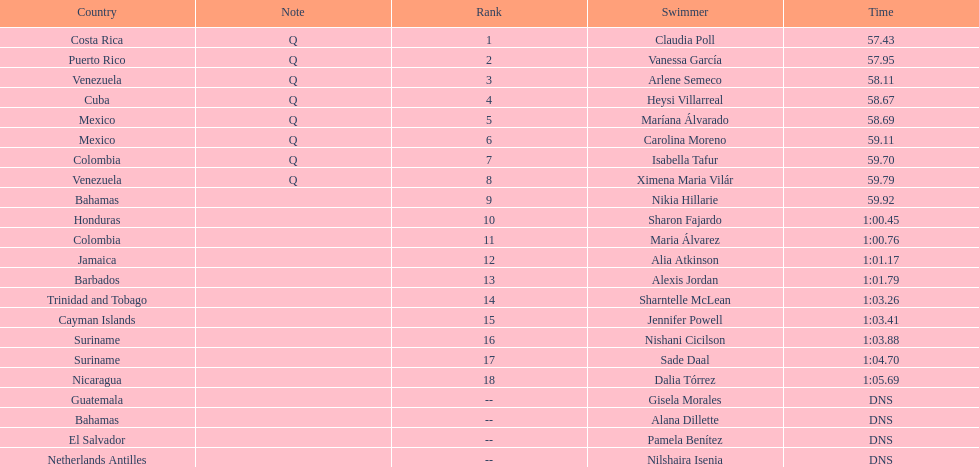How many competitors did not start the preliminaries? 4. 